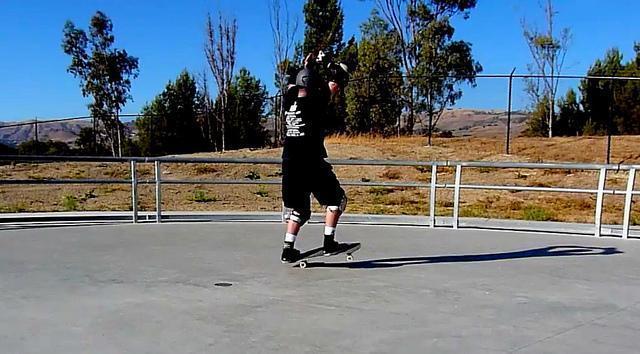How many cars have zebra stripes?
Give a very brief answer. 0. 